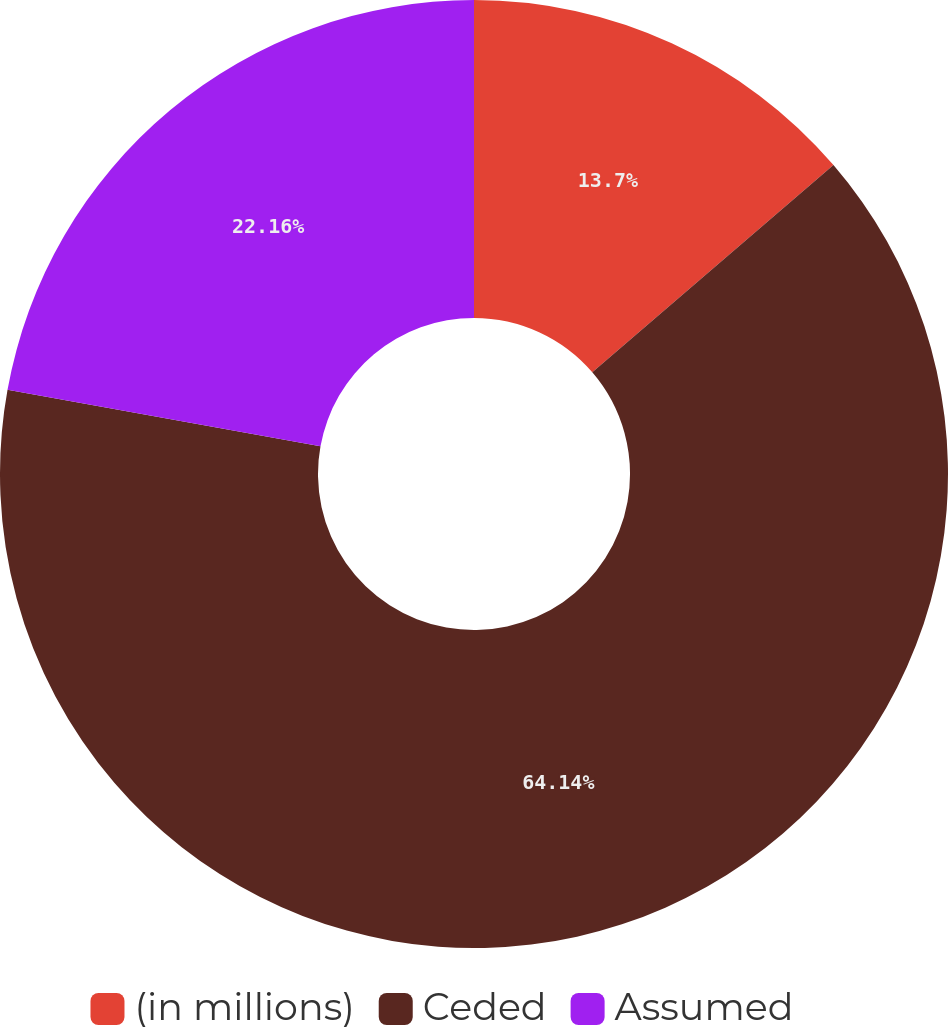Convert chart to OTSL. <chart><loc_0><loc_0><loc_500><loc_500><pie_chart><fcel>(in millions)<fcel>Ceded<fcel>Assumed<nl><fcel>13.7%<fcel>64.14%<fcel>22.16%<nl></chart> 